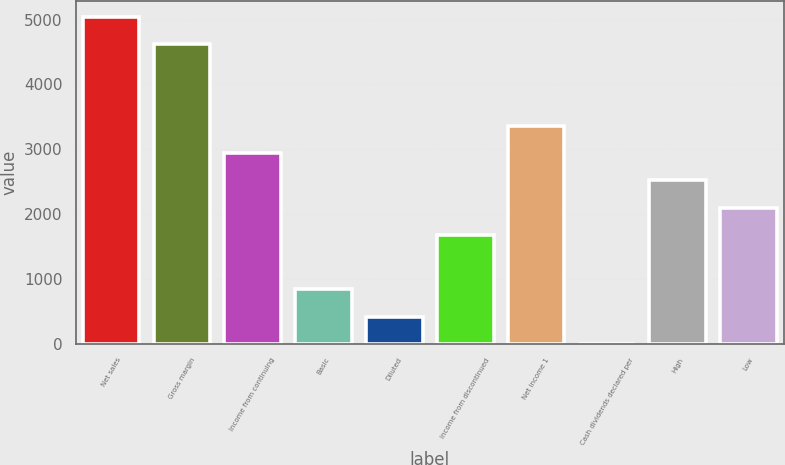<chart> <loc_0><loc_0><loc_500><loc_500><bar_chart><fcel>Net sales<fcel>Gross margin<fcel>Income from continuing<fcel>Basic<fcel>Diluted<fcel>Income from discontinued<fcel>Net income 1<fcel>Cash dividends declared per<fcel>High<fcel>Low<nl><fcel>5036.32<fcel>4616.67<fcel>2938.07<fcel>839.82<fcel>420.17<fcel>1679.12<fcel>3357.72<fcel>0.52<fcel>2518.42<fcel>2098.77<nl></chart> 